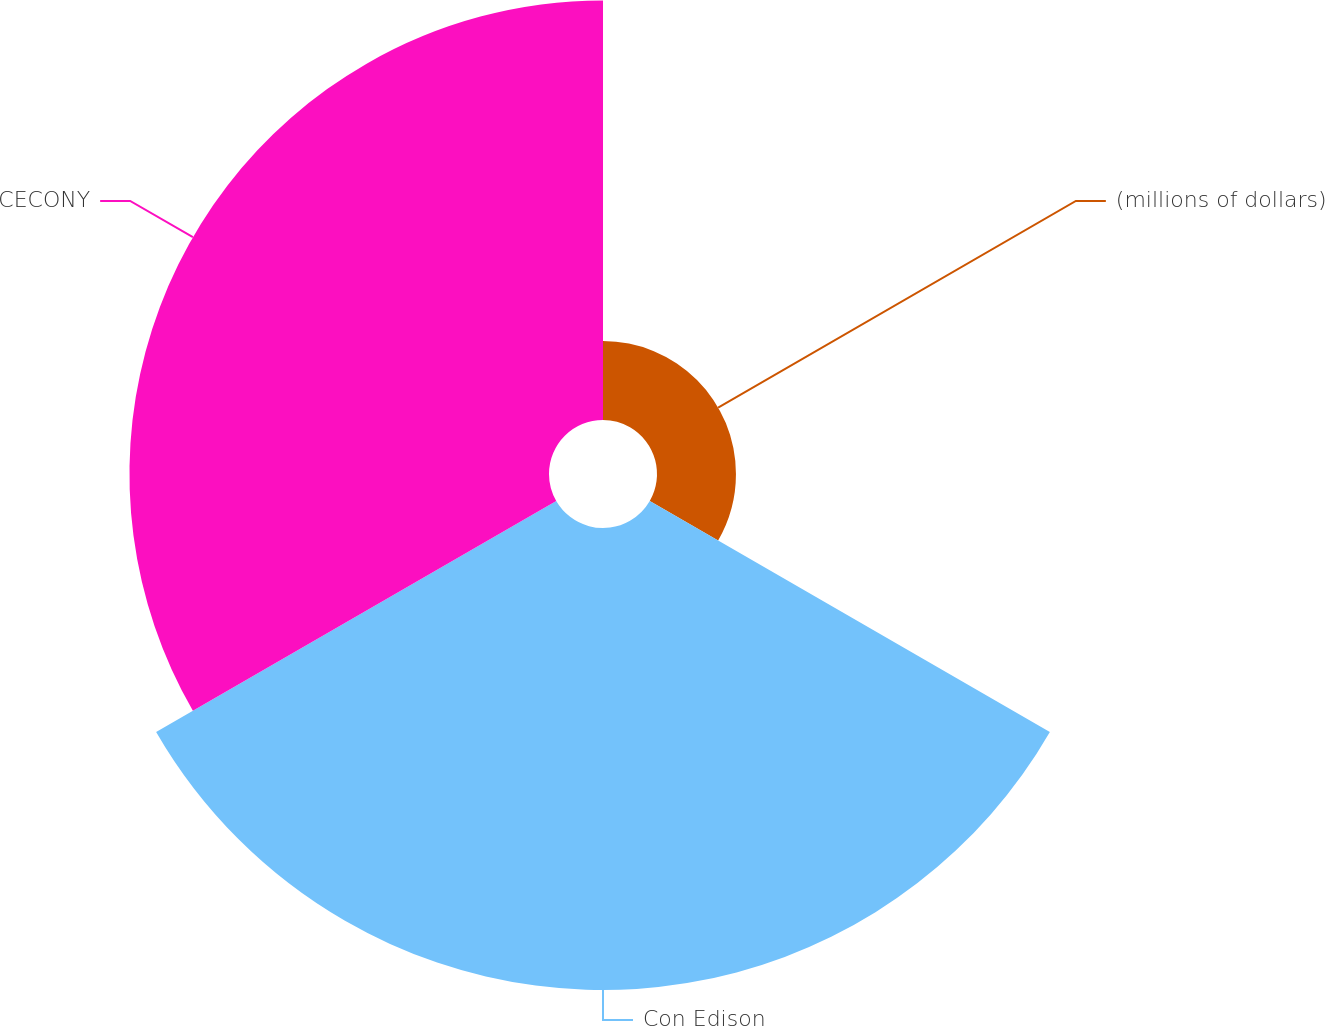Convert chart to OTSL. <chart><loc_0><loc_0><loc_500><loc_500><pie_chart><fcel>(millions of dollars)<fcel>Con Edison<fcel>CECONY<nl><fcel>8.22%<fcel>48.1%<fcel>43.68%<nl></chart> 